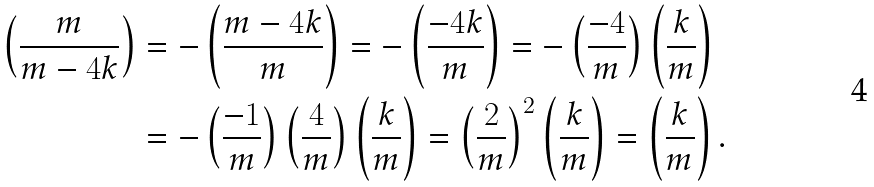Convert formula to latex. <formula><loc_0><loc_0><loc_500><loc_500>\left ( \frac { m } { m - 4 k } \right ) & = - \left ( \frac { m - 4 k } { m } \right ) = - \left ( \frac { - 4 k } { m } \right ) = - \left ( \frac { - 4 } { m } \right ) \left ( \frac { k } { m } \right ) \\ & = - \left ( \frac { - 1 } { m } \right ) \left ( \frac { 4 } { m } \right ) \left ( \frac { k } { m } \right ) = \left ( \frac { 2 } { m } \right ) ^ { 2 } \left ( \frac { k } { m } \right ) = \left ( \frac { k } { m } \right ) .</formula> 